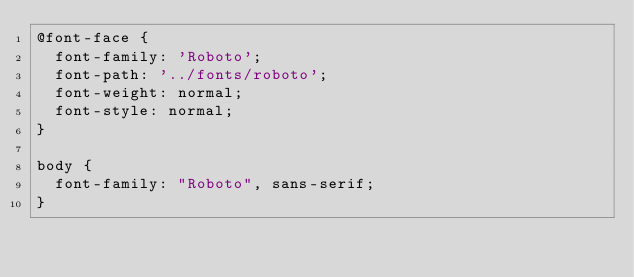<code> <loc_0><loc_0><loc_500><loc_500><_CSS_>@font-face {
  font-family: 'Roboto';
  font-path: '../fonts/roboto';
  font-weight: normal;
  font-style: normal;
}

body {
  font-family: "Roboto", sans-serif;
}
</code> 